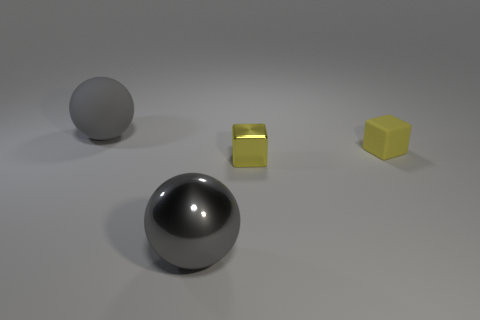Do the yellow cube to the left of the matte block and the sphere in front of the tiny metallic thing have the same material?
Provide a short and direct response. Yes. Is the number of big metal balls behind the matte ball the same as the number of big gray matte things that are in front of the matte cube?
Make the answer very short. Yes. How many things have the same color as the metal sphere?
Give a very brief answer. 1. There is a tiny block that is the same color as the tiny metal thing; what is it made of?
Provide a short and direct response. Rubber. What number of matte objects are small blocks or big balls?
Your response must be concise. 2. Do the small yellow thing in front of the tiny yellow matte block and the tiny matte object that is right of the gray metal ball have the same shape?
Your answer should be very brief. Yes. What number of things are behind the yellow matte block?
Provide a succinct answer. 1. There is a gray ball that is the same size as the gray metal thing; what material is it?
Your response must be concise. Rubber. How many objects are either spheres or big gray rubber objects?
Offer a very short reply. 2. What shape is the gray object that is to the right of the matte sphere?
Keep it short and to the point. Sphere. 